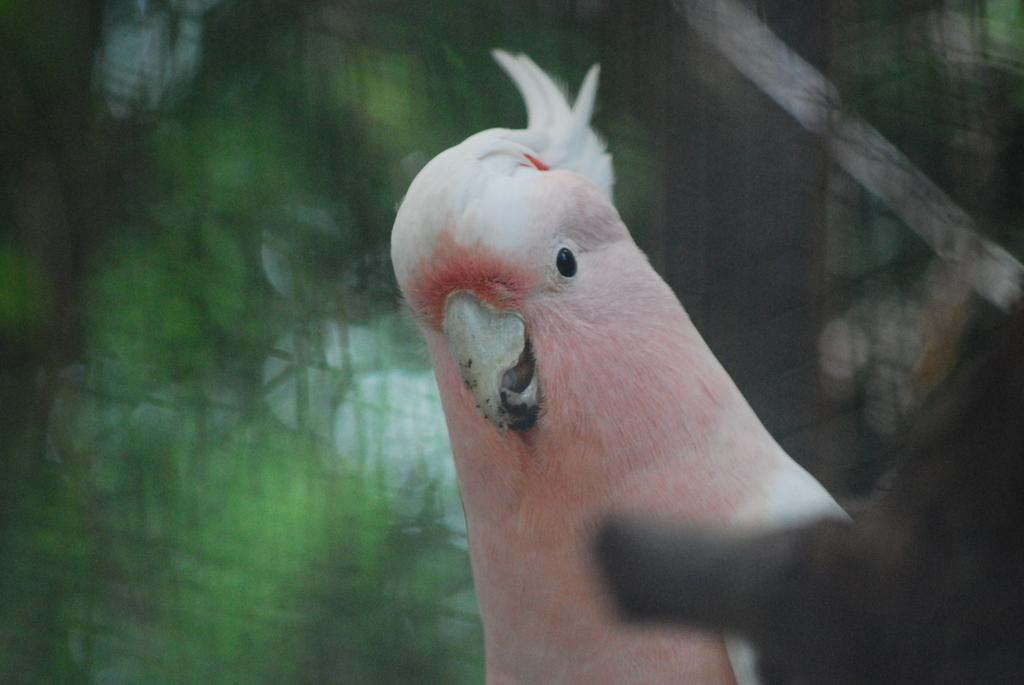What type of animal can be seen in the image? There is a bird in the image. Can you describe the background of the image? The background of the image is blurry. What type of glue is the bird using to stick its wing in the image? There is no glue or indication of the bird using glue in the image. 